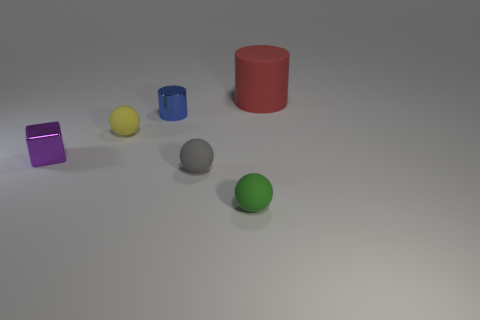How many objects are either cylinders that are in front of the red cylinder or tiny gray objects?
Offer a very short reply. 2. There is a blue thing that is the same size as the gray rubber ball; what material is it?
Your answer should be compact. Metal. The cylinder that is on the right side of the tiny rubber ball to the right of the gray sphere is what color?
Your response must be concise. Red. There is a tiny purple cube; what number of tiny matte spheres are in front of it?
Keep it short and to the point. 2. What is the color of the matte cylinder?
Provide a succinct answer. Red. How many big objects are either gray metallic things or yellow things?
Offer a terse response. 0. There is a rubber object that is to the left of the shiny cylinder; what shape is it?
Ensure brevity in your answer.  Sphere. Is the number of small blocks less than the number of big cyan cubes?
Give a very brief answer. No. Does the tiny sphere behind the purple metal cube have the same material as the gray ball?
Provide a succinct answer. Yes. Is there anything else that has the same size as the red matte cylinder?
Your answer should be very brief. No. 